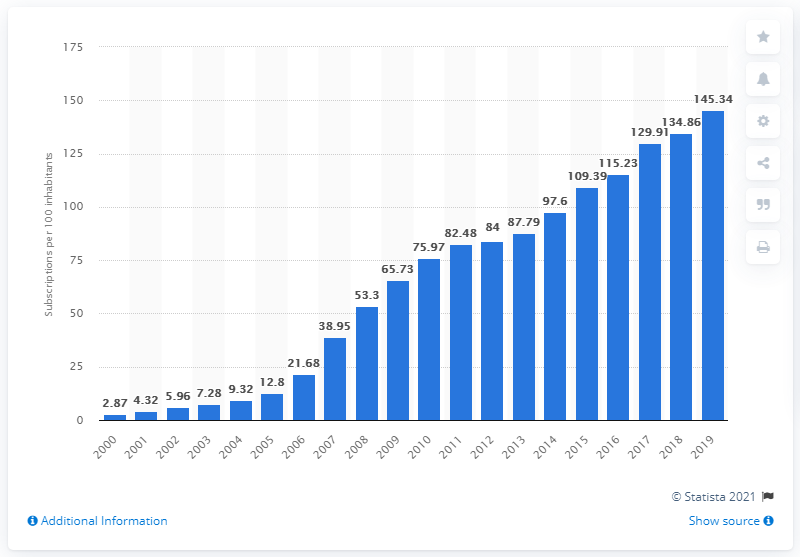Highlight a few significant elements in this photo. In the year 2000, there were approximately 200 mobile cellular subscriptions per 100 inhabitants in C te d'Ivoire. As of 2019, the number of mobile subscriptions per 100 people in C 